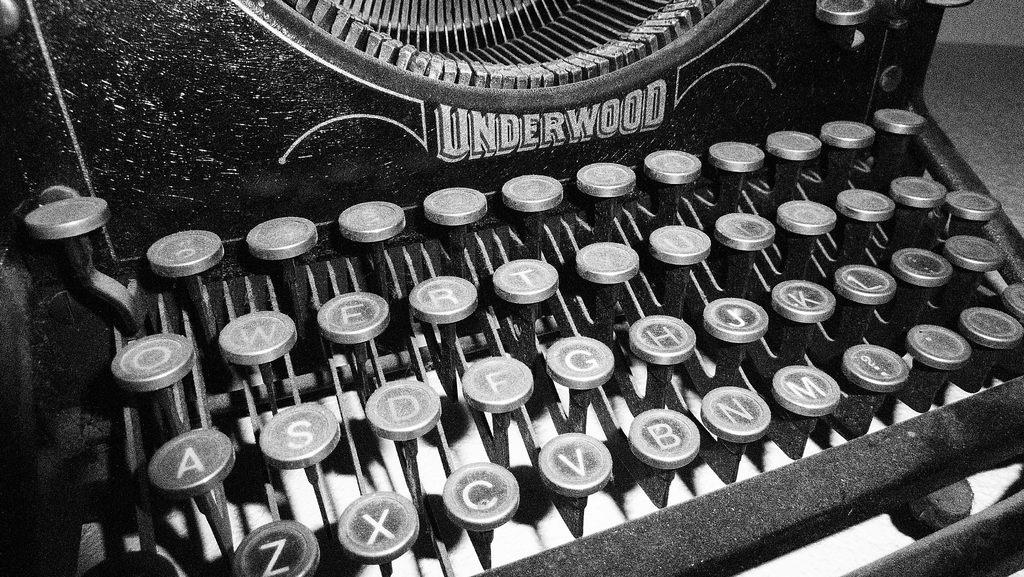<image>
Offer a succinct explanation of the picture presented. An old underwood typewriter with a qwerty keyboard. 